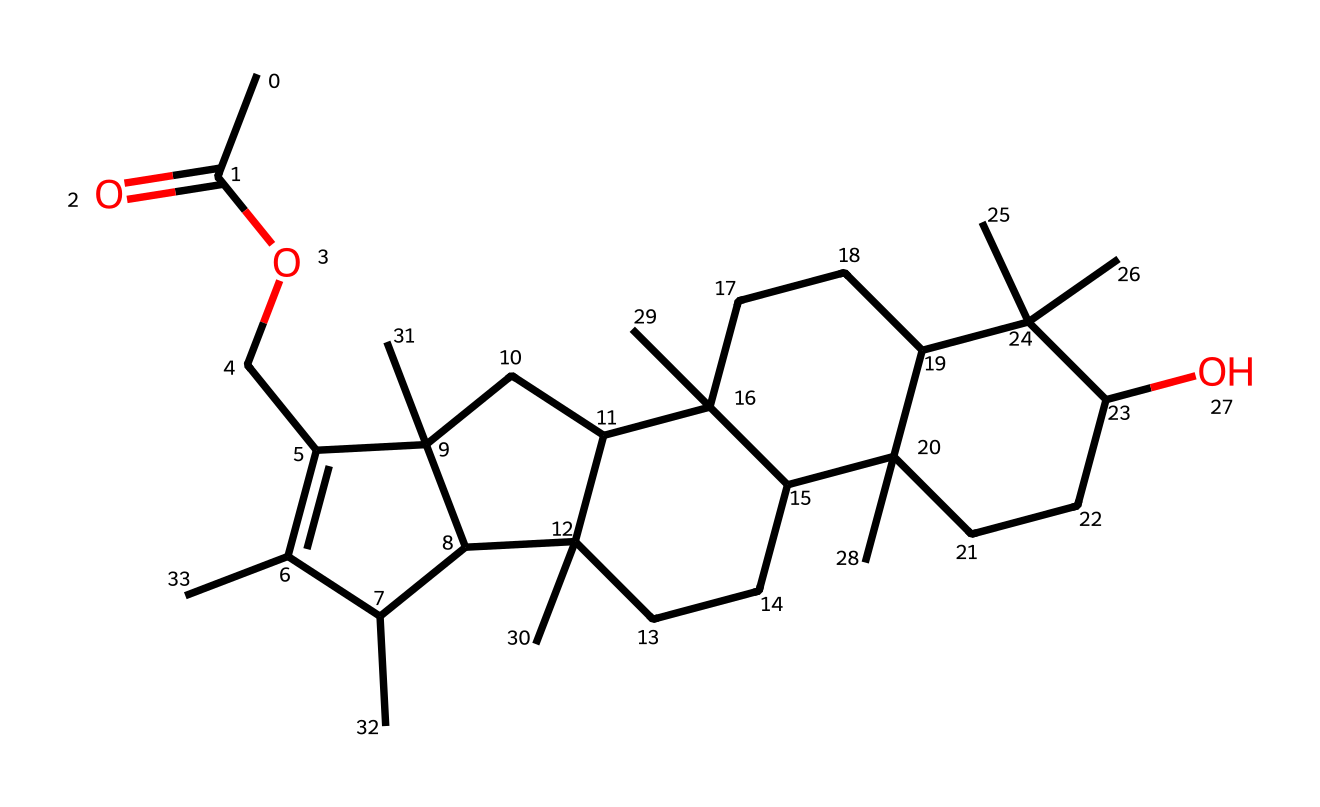how many carbon atoms are in the chemical structure? By observing the SMILES representation, we can count the 'C' symbols which denote carbon atoms throughout the structure. When counted, there are a total of 27 carbon atoms.
Answer: 27 how many oxygen atoms are in the chemical structure? In the given SMILES representation, we can identify the 'O' symbols that indicate oxygen atoms. Counting these, we find there are 3 oxygen atoms present in the chemical structure.
Answer: 3 what is the primary functional group in neem oil? The presence of the 'CC(=O)' indicates that there is a carbonyl group (C=O) attached to a carbon chain, which classifies this as an ester functional group.
Answer: ester does this chemical structure indicate it can function as a pesticide? The presence of multiple cyclic structures and specific functional groups suggests potential bioactivity, particularly for pest repellency, which is characteristic of pesticides like neem oil.
Answer: yes what type of chemical compound is neem oil categorized as based on its structure? The complex structure includes a large carbon skeleton and functional groups that exhibit the characteristics of a natural product, thus categorizing neem oil as a terpenoid.
Answer: terpenoid how many double bonds are present in the chemical structure? By looking for the '=' signs in the SMILES notation, we can see there are four double bonds present in this chemical structure.
Answer: 4 which part of the chemical contributes to its natural pesticide properties? The unique arrangement of carbon chains and functional groups specifically allows neem oil to interact with insect hormones, making the ring structures and certain functional groups central to its efficacy as a pesticide.
Answer: ring structures and functional groups 